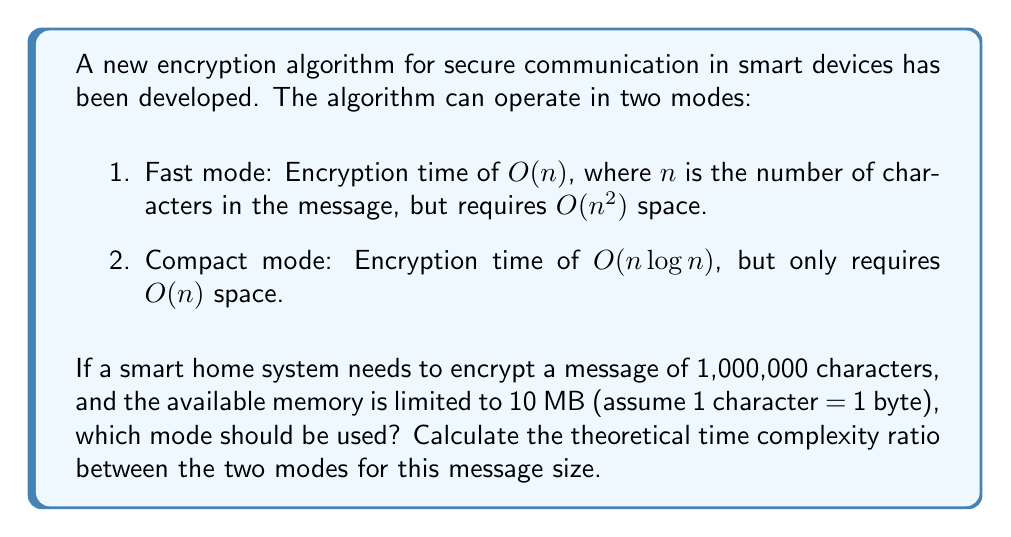Help me with this question. To solve this problem, we need to follow these steps:

1. Determine if the Compact mode is necessary due to memory constraints:
   - Fast mode space requirement: $O(n^2)$ = $1,000,000^2$ bytes = $10^{12}$ bytes = 1 TB
   - Available memory: 10 MB = $10 \times 10^6$ bytes
   - Compact mode space requirement: $O(n)$ = 1,000,000 bytes = 1 MB

   Clearly, the Fast mode exceeds the available memory, so we must use the Compact mode.

2. Calculate the time complexity for each mode:
   - Fast mode: $O(n)$ = $O(1,000,000)$ = $10^6$
   - Compact mode: $O(n \log n)$ = $O(1,000,000 \times \log 1,000,000)$
                 = $O(1,000,000 \times 20)$ (since $\log_2 1,000,000 \approx 19.93$)
                 = $O(20,000,000)$ = $2 \times 10^7$

3. Calculate the theoretical time complexity ratio:
   $$\text{Ratio} = \frac{\text{Compact mode complexity}}{\text{Fast mode complexity}} = \frac{2 \times 10^7}{10^6} = 20$$

This means that theoretically, the Compact mode would take about 20 times longer than the Fast mode for this message size.
Answer: The Compact mode should be used due to memory constraints. The theoretical time complexity ratio between the Compact mode and the Fast mode for a message of 1,000,000 characters is 20:1. 